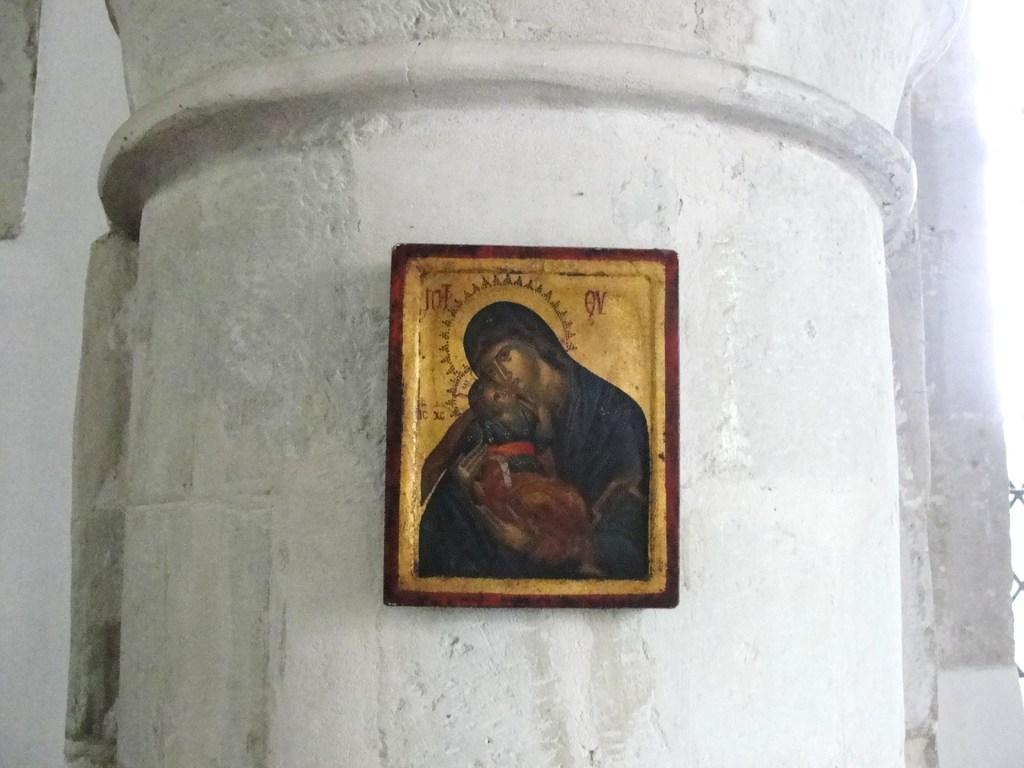What object is present in the image that is typically used for displaying photos? There is a photo frame in the image. Where is the photo frame located in relation to other objects or structures? The photo frame is attached to a pillar. What can be seen in the background of the image? There is a wall in the background of the image. What type of stocking is visible on the pillar in the image? There is no stocking present on the pillar or anywhere else in the image. How does the stick help the photo frame in the image? There is no stick present in the image, and therefore it cannot help the photo frame. 